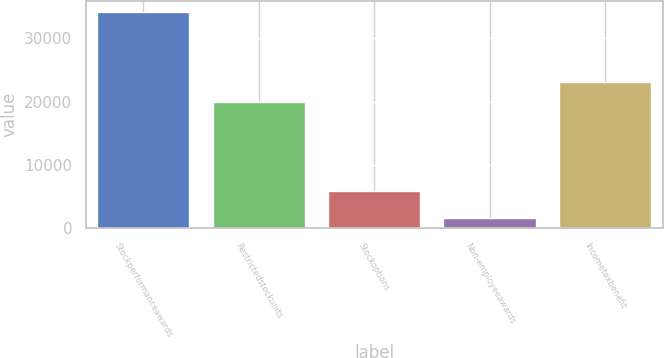<chart> <loc_0><loc_0><loc_500><loc_500><bar_chart><fcel>Stockperformanceawards<fcel>Restrictedstockunits<fcel>Stockoptions<fcel>Non-employeeawards<fcel>Incometaxbenefit<nl><fcel>34248<fcel>19908<fcel>5838<fcel>1630<fcel>23169.8<nl></chart> 